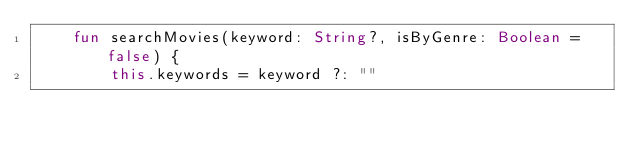<code> <loc_0><loc_0><loc_500><loc_500><_Kotlin_>    fun searchMovies(keyword: String?, isByGenre: Boolean = false) {
        this.keywords = keyword ?: ""</code> 